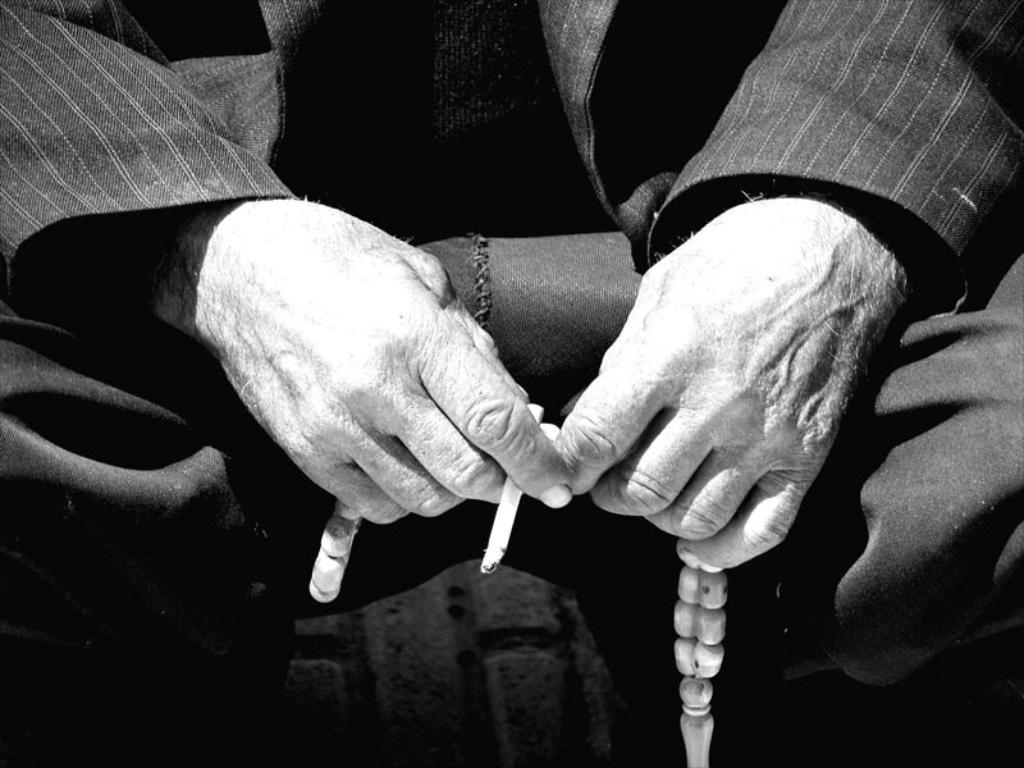What is the main subject of the image? There is a person in the image. What is the person holding in his hand? The person is holding a cigarette and another object. What is the color scheme of the image? The image is in black and white. What type of cloud can be seen in the image? There are no clouds present in the image, as it is in black and white and does not depict any outdoor scene. 